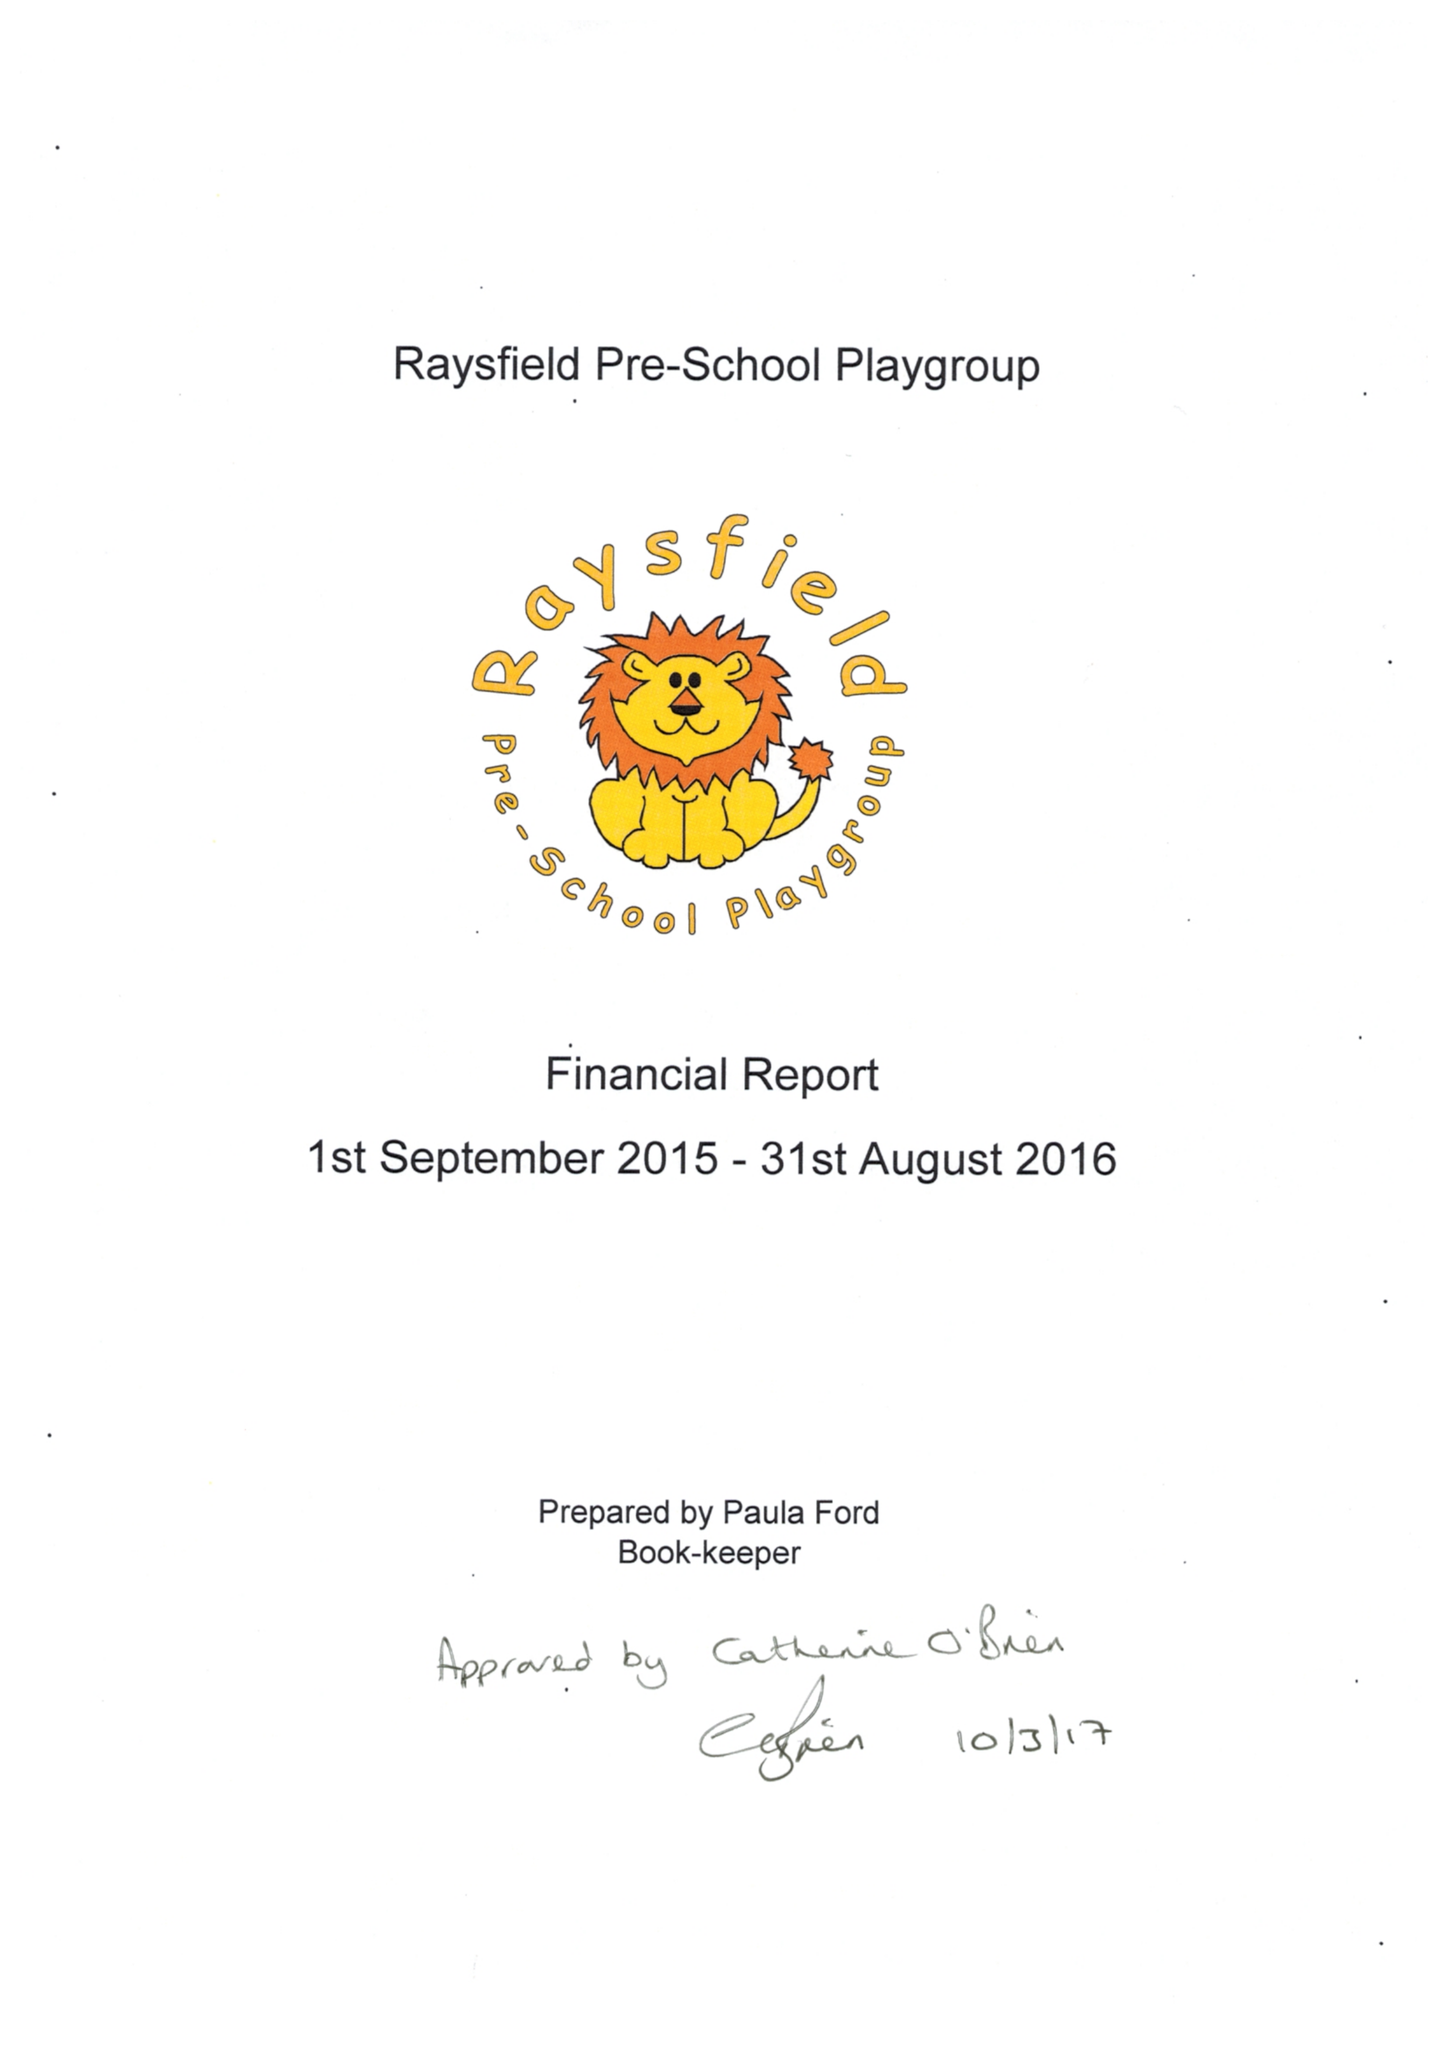What is the value for the address__postcode?
Answer the question using a single word or phrase. BS37 6JZ 